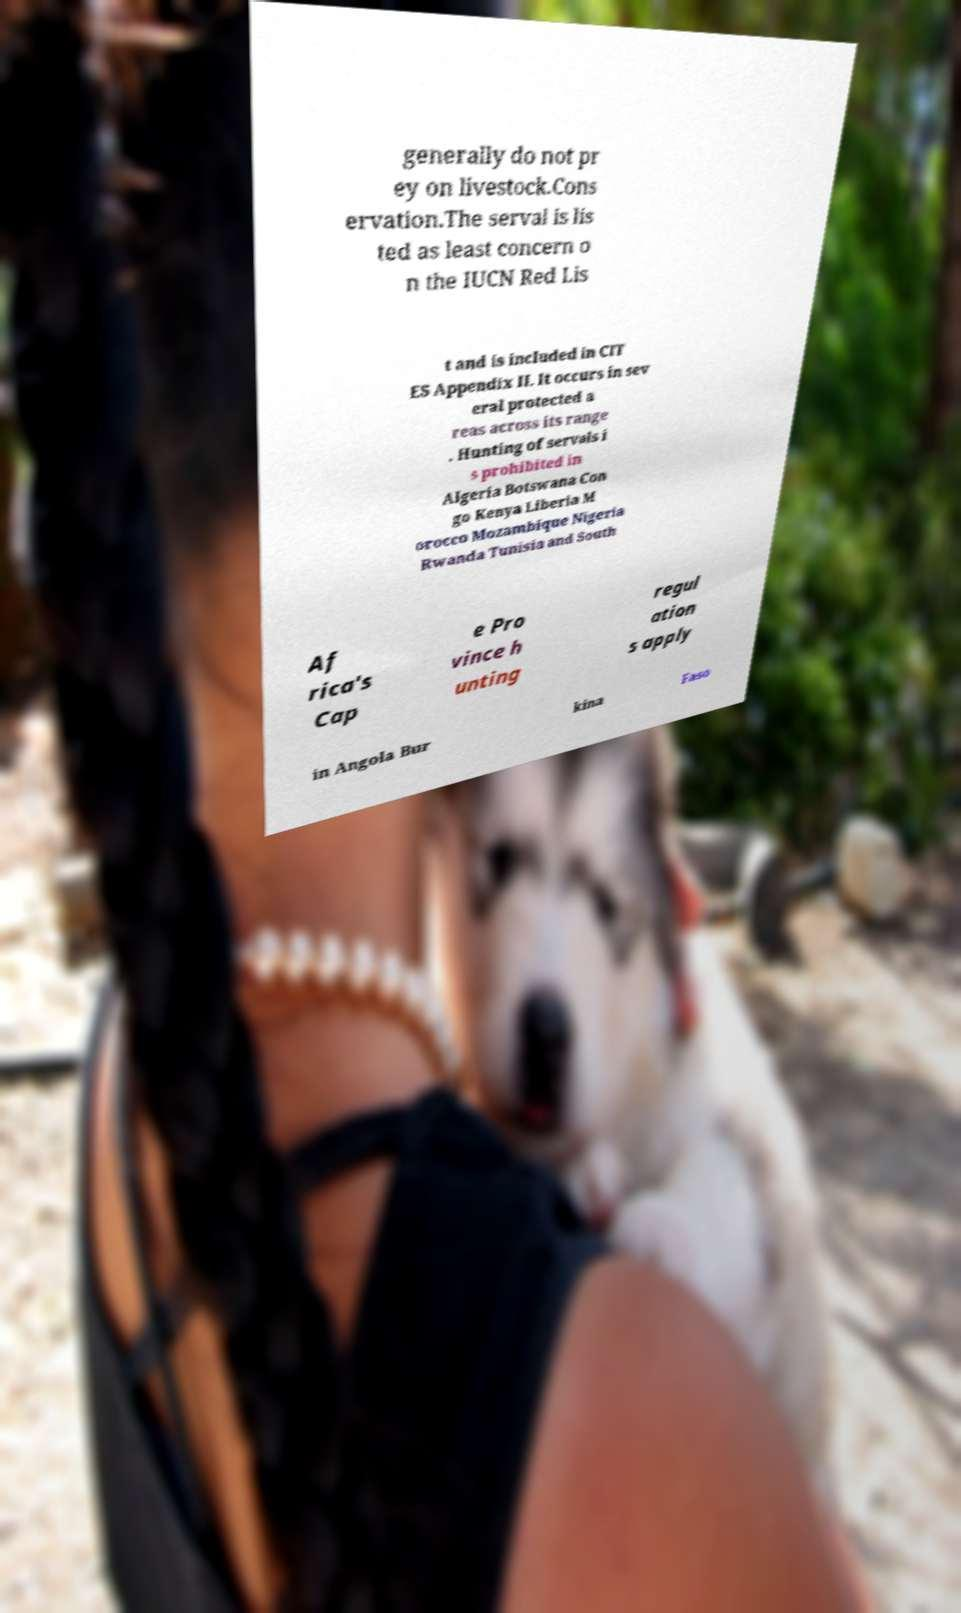For documentation purposes, I need the text within this image transcribed. Could you provide that? generally do not pr ey on livestock.Cons ervation.The serval is lis ted as least concern o n the IUCN Red Lis t and is included in CIT ES Appendix II. It occurs in sev eral protected a reas across its range . Hunting of servals i s prohibited in Algeria Botswana Con go Kenya Liberia M orocco Mozambique Nigeria Rwanda Tunisia and South Af rica's Cap e Pro vince h unting regul ation s apply in Angola Bur kina Faso 